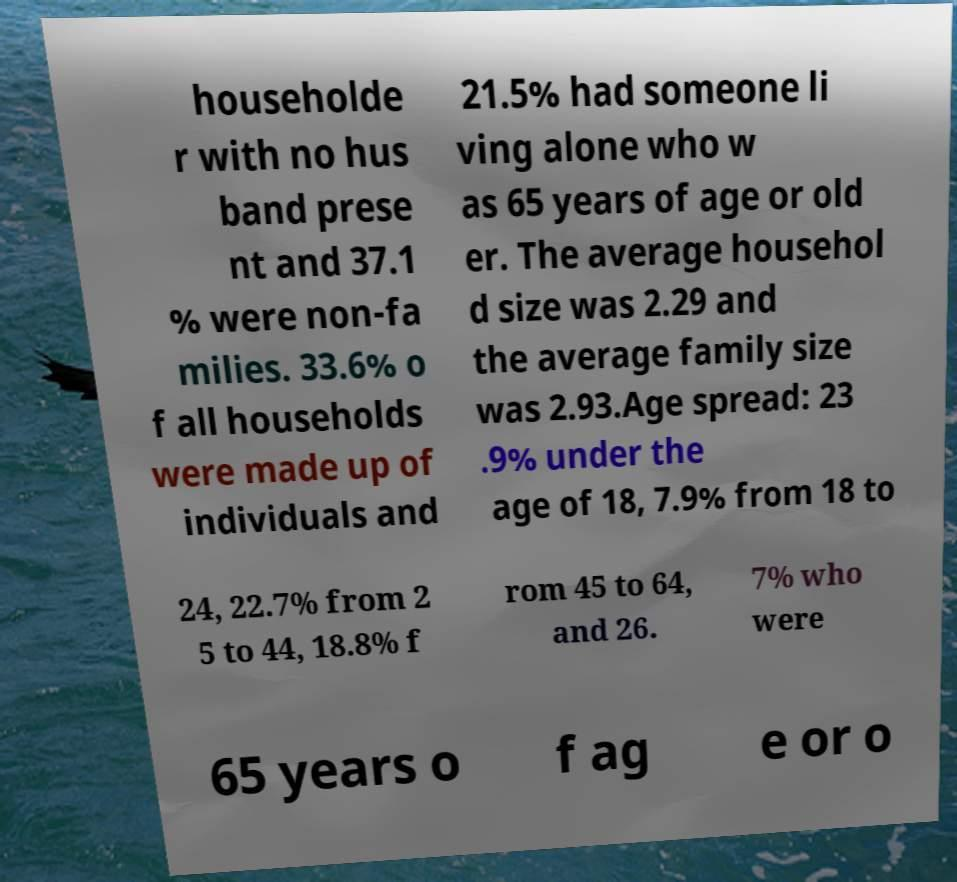For documentation purposes, I need the text within this image transcribed. Could you provide that? householde r with no hus band prese nt and 37.1 % were non-fa milies. 33.6% o f all households were made up of individuals and 21.5% had someone li ving alone who w as 65 years of age or old er. The average househol d size was 2.29 and the average family size was 2.93.Age spread: 23 .9% under the age of 18, 7.9% from 18 to 24, 22.7% from 2 5 to 44, 18.8% f rom 45 to 64, and 26. 7% who were 65 years o f ag e or o 